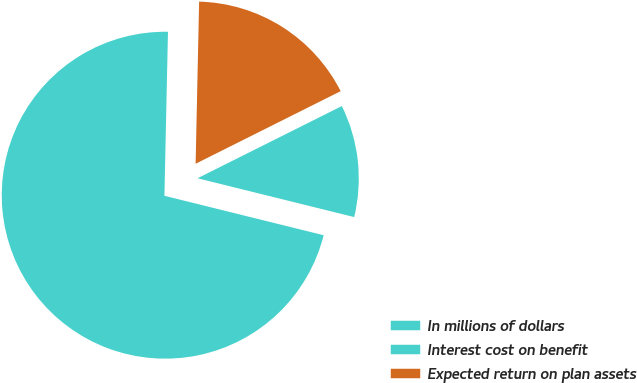Convert chart. <chart><loc_0><loc_0><loc_500><loc_500><pie_chart><fcel>In millions of dollars<fcel>Interest cost on benefit<fcel>Expected return on plan assets<nl><fcel>71.48%<fcel>11.25%<fcel>17.27%<nl></chart> 